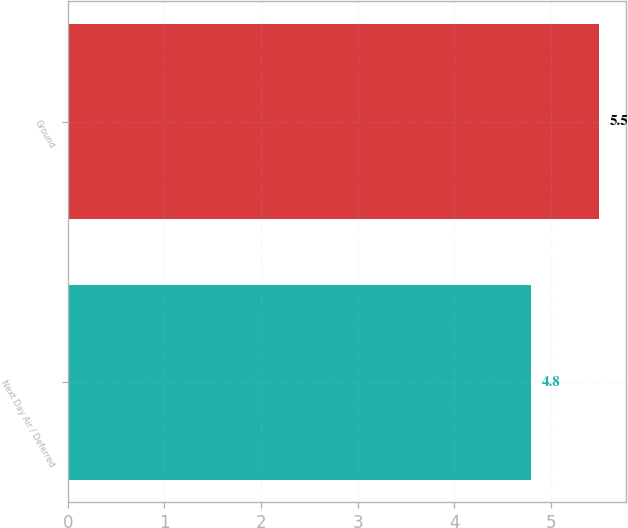<chart> <loc_0><loc_0><loc_500><loc_500><bar_chart><fcel>Next Day Air / Deferred<fcel>Ground<nl><fcel>4.8<fcel>5.5<nl></chart> 